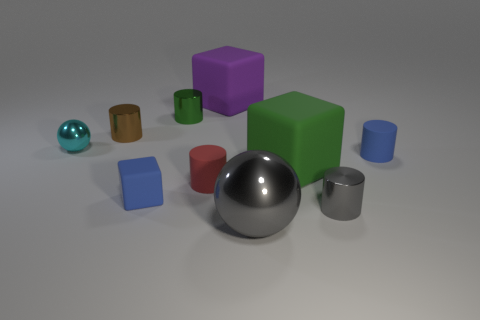Subtract all blue balls. Subtract all gray cubes. How many balls are left? 2 Subtract all balls. How many objects are left? 8 Add 5 brown objects. How many brown objects exist? 6 Subtract 0 yellow cylinders. How many objects are left? 10 Subtract all yellow cubes. Subtract all purple things. How many objects are left? 9 Add 6 blue matte blocks. How many blue matte blocks are left? 7 